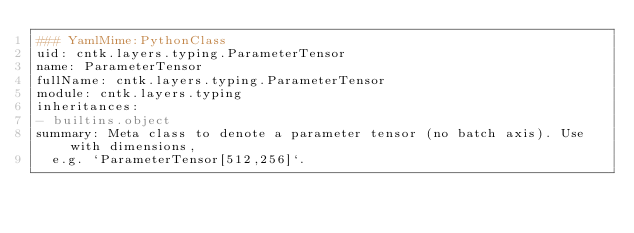Convert code to text. <code><loc_0><loc_0><loc_500><loc_500><_YAML_>### YamlMime:PythonClass
uid: cntk.layers.typing.ParameterTensor
name: ParameterTensor
fullName: cntk.layers.typing.ParameterTensor
module: cntk.layers.typing
inheritances:
- builtins.object
summary: Meta class to denote a parameter tensor (no batch axis). Use with dimensions,
  e.g. `ParameterTensor[512,256]`.
</code> 